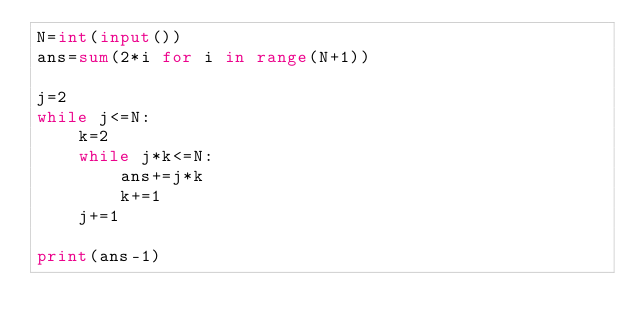Convert code to text. <code><loc_0><loc_0><loc_500><loc_500><_Python_>N=int(input())
ans=sum(2*i for i in range(N+1))

j=2
while j<=N:
    k=2
    while j*k<=N:
        ans+=j*k
        k+=1
    j+=1

print(ans-1)</code> 